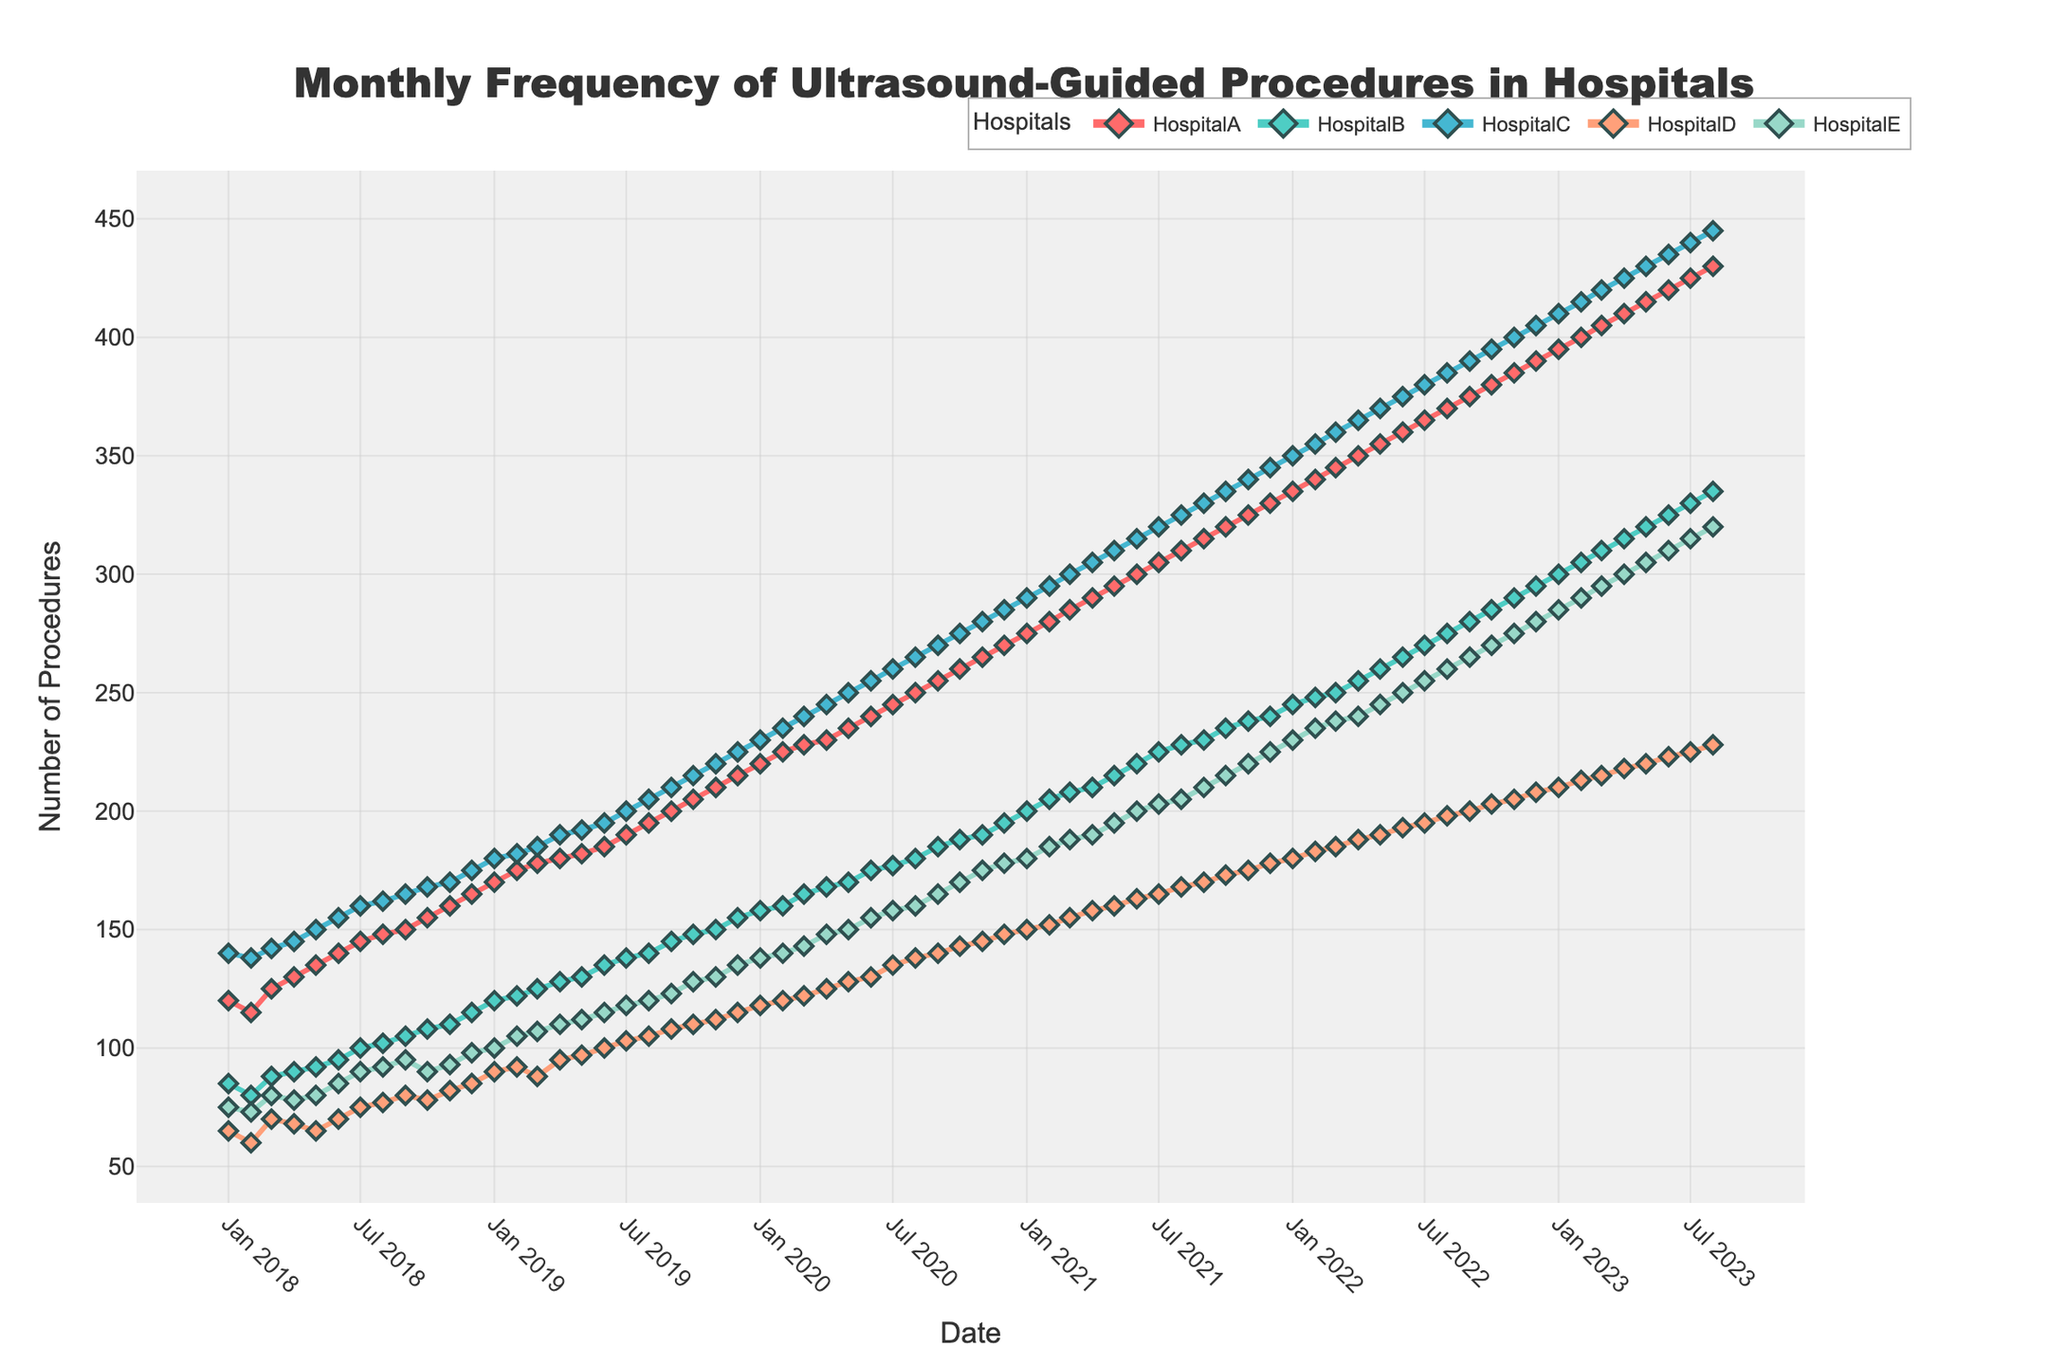What is the title of the figure? The title is located at the top of the figure, typically in larger and bold text for emphasis. This helps to quickly identify the subject of the chart.
Answer: Monthly Frequency of Ultrasound-Guided Procedures in Hospitals What are the names of the hospitals included in the figure? The hospital names are listed in the legend area, each associated with a specific line color.
Answer: HospitalA, HospitalB, HospitalC, HospitalD, HospitalE Between which months did HospitalA show the steepest increase in procedures? By examining the slope of the line representing HospitalA's procedures, the steepest increase appears between December 2018 and January 2023. Look for the interval with the steepest slope.
Answer: January 2020 to February 2020 How does the number of procedures in HospitalB compare to HospitalD in July 2019? Locate the data points for July 2019 for both HospitalB and HospitalD to compare their values.
Answer: HospitalB: 138, HospitalD: 103 Which hospital had the highest number of procedures in January 2021? Find the plotted point for January 2021 for each hospital and compare them to determine which is the highest.
Answer: HospitalA During which year did HospitalE see the greatest increase in the number of procedures? Examine the trend of HospitalE year by year and identify the year with the largest positive change from January to December.
Answer: 2020 What is the trend in the frequency of procedures for HospitalA over the five years? Look at the overall pattern of HospitalA's line across the full time period to identify if it is generally increasing, decreasing, or stable.
Answer: Increasing Which hospital shows the most consistent number of procedures over time? Identify the hospital line that has the least variation and most stable trend across the entire period.
Answer: HospitalB 